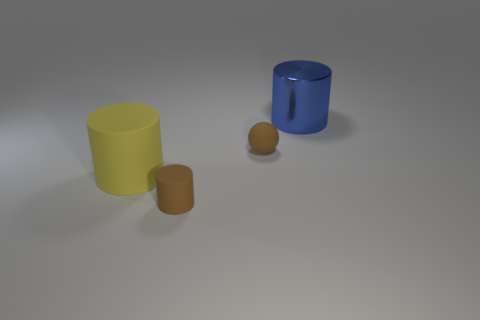There is a big cylinder that is behind the big cylinder that is left of the cylinder behind the yellow cylinder; what is its color?
Your response must be concise. Blue. How many other things are the same size as the metal object?
Your answer should be compact. 1. Is there anything else that has the same shape as the blue metallic object?
Ensure brevity in your answer.  Yes. What is the color of the tiny object that is the same shape as the big blue shiny object?
Offer a terse response. Brown. What color is the large cylinder that is the same material as the tiny cylinder?
Offer a very short reply. Yellow. Are there the same number of yellow things that are to the right of the big blue metallic object and large blue cylinders?
Ensure brevity in your answer.  No. There is a thing that is in front of the yellow cylinder; does it have the same size as the big blue metal cylinder?
Your answer should be compact. No. What color is the rubber cylinder that is the same size as the blue shiny object?
Offer a very short reply. Yellow. There is a rubber cylinder behind the small brown thing that is in front of the yellow object; is there a big yellow matte object behind it?
Provide a short and direct response. No. There is a large thing to the left of the big metal thing; what material is it?
Your answer should be very brief. Rubber. 